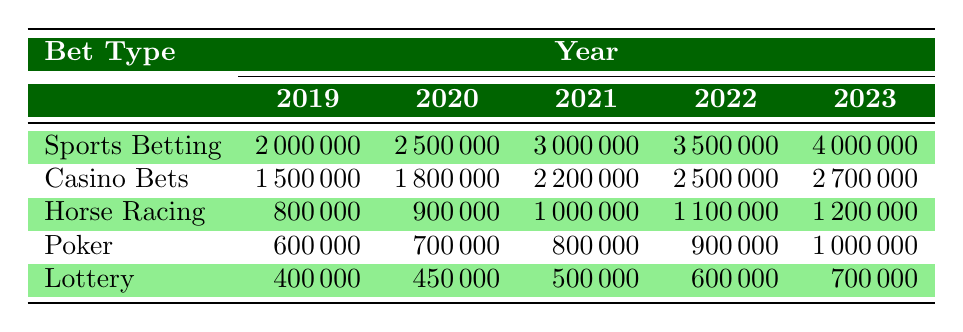What was the revenue from casino bets in 2021? The table shows the revenue from casino bets for each year. In 2021, the revenue is listed as 2,200,000.
Answer: 2,200,000 Which type of bet had the highest revenue in 2023? By looking at 2023, the table lists the revenues for all bet types. Sports betting with 4,000,000 is the highest compared to the others.
Answer: Sports betting How much more did sports betting earn in 2022 compared to 2020? In 2022, sports betting earned 3,500,000, and in 2020, it earned 2,500,000. The difference is 3,500,000 - 2,500,000 = 1,000,000.
Answer: 1,000,000 What is the total revenue from horse racing over the last five years? To find the total revenue for horse racing, we need to sum the values for each year: 800,000 + 900,000 + 1,000,000 + 1,100,000 + 1,200,000 = 5,000,000.
Answer: 5,000,000 Did the revenue from poker decrease from 2019 to 2020? In 2019, the revenue from poker was 600,000 and in 2020, it increased to 700,000. Therefore, the revenue did not decrease; it increased.
Answer: No What was the percentage increase in lottery revenue from 2019 to 2023? The lottery revenue in 2019 was 400,000 and in 2023 it was 700,000. The increase is 700,000 - 400,000 = 300,000. The percentage increase is (300,000 / 400,000) * 100 = 75%.
Answer: 75% Which bet type has the least revenue in 2020 and what was that revenue? In 2020, the table shows the revenue for each type of bet. Lottery has the least revenue at 450,000.
Answer: 450,000 What is the average revenue of casino bets over the five years? The casino bets revenue for each year is: 1,500,000 (2019), 1,800,000 (2020), 2,200,000 (2021), 2,500,000 (2022), and 2,700,000 (2023). Summing these gives 10,700,000, and dividing by 5 gives an average of 2,140,000.
Answer: 2,140,000 Has the revenue from horse racing been consistently increasing every year? Analyzing the horse racing revenue: 800,000 (2019), 900,000 (2020), 1,000,000 (2021), 1,100,000 (2022), and 1,200,000 (2023), shows a consistent increase each year.
Answer: Yes In which year did poker revenue exceed 900,000 for the first time? The poker revenue values are 600,000 (2019), 700,000 (2020), 800,000 (2021), 900,000 (2022), and 1,000,000 (2023). It exceeded 900,000 for the first time in 2023.
Answer: 2023 